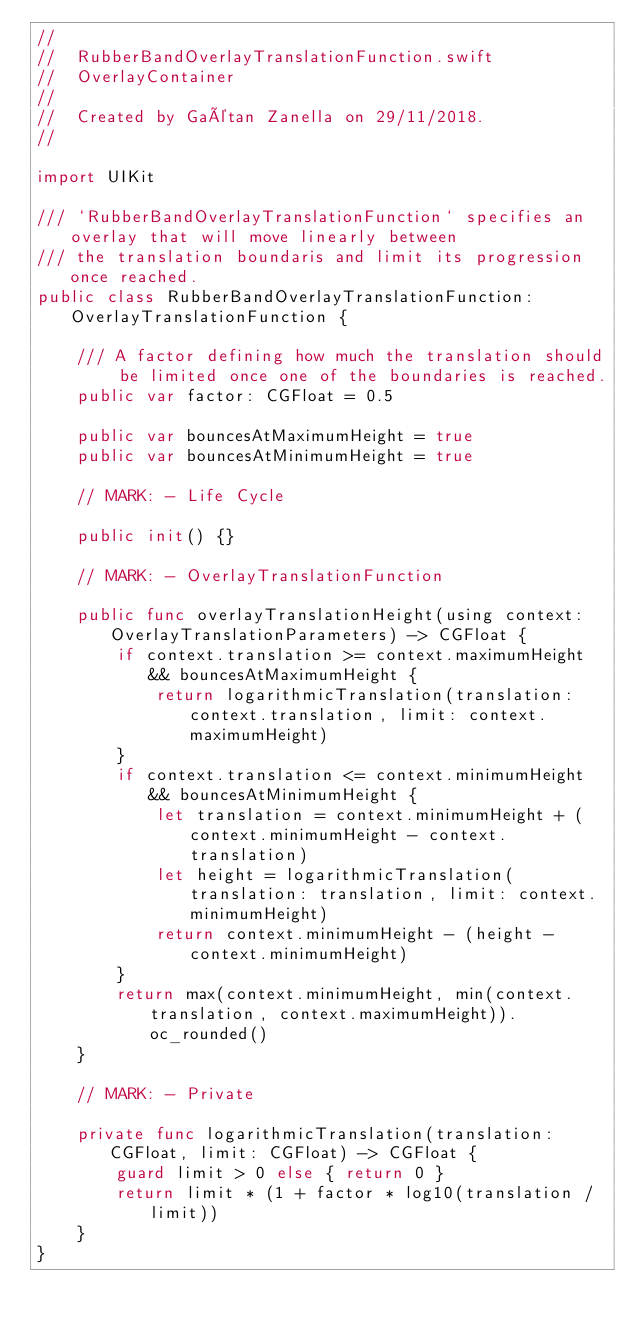Convert code to text. <code><loc_0><loc_0><loc_500><loc_500><_Swift_>//
//  RubberBandOverlayTranslationFunction.swift
//  OverlayContainer
//
//  Created by Gaétan Zanella on 29/11/2018.
//

import UIKit

/// `RubberBandOverlayTranslationFunction` specifies an overlay that will move linearly between
/// the translation boundaris and limit its progression once reached.
public class RubberBandOverlayTranslationFunction: OverlayTranslationFunction {

    /// A factor defining how much the translation should be limited once one of the boundaries is reached.
    public var factor: CGFloat = 0.5

    public var bouncesAtMaximumHeight = true
    public var bouncesAtMinimumHeight = true

    // MARK: - Life Cycle

    public init() {}

    // MARK: - OverlayTranslationFunction

    public func overlayTranslationHeight(using context: OverlayTranslationParameters) -> CGFloat {
        if context.translation >= context.maximumHeight && bouncesAtMaximumHeight {
            return logarithmicTranslation(translation: context.translation, limit: context.maximumHeight)
        }
        if context.translation <= context.minimumHeight && bouncesAtMinimumHeight {
            let translation = context.minimumHeight + (context.minimumHeight - context.translation)
            let height = logarithmicTranslation(translation: translation, limit: context.minimumHeight)
            return context.minimumHeight - (height - context.minimumHeight)
        }
        return max(context.minimumHeight, min(context.translation, context.maximumHeight)).oc_rounded()
    }

    // MARK: - Private

    private func logarithmicTranslation(translation: CGFloat, limit: CGFloat) -> CGFloat {
        guard limit > 0 else { return 0 }
        return limit * (1 + factor * log10(translation / limit))
    }
}
</code> 